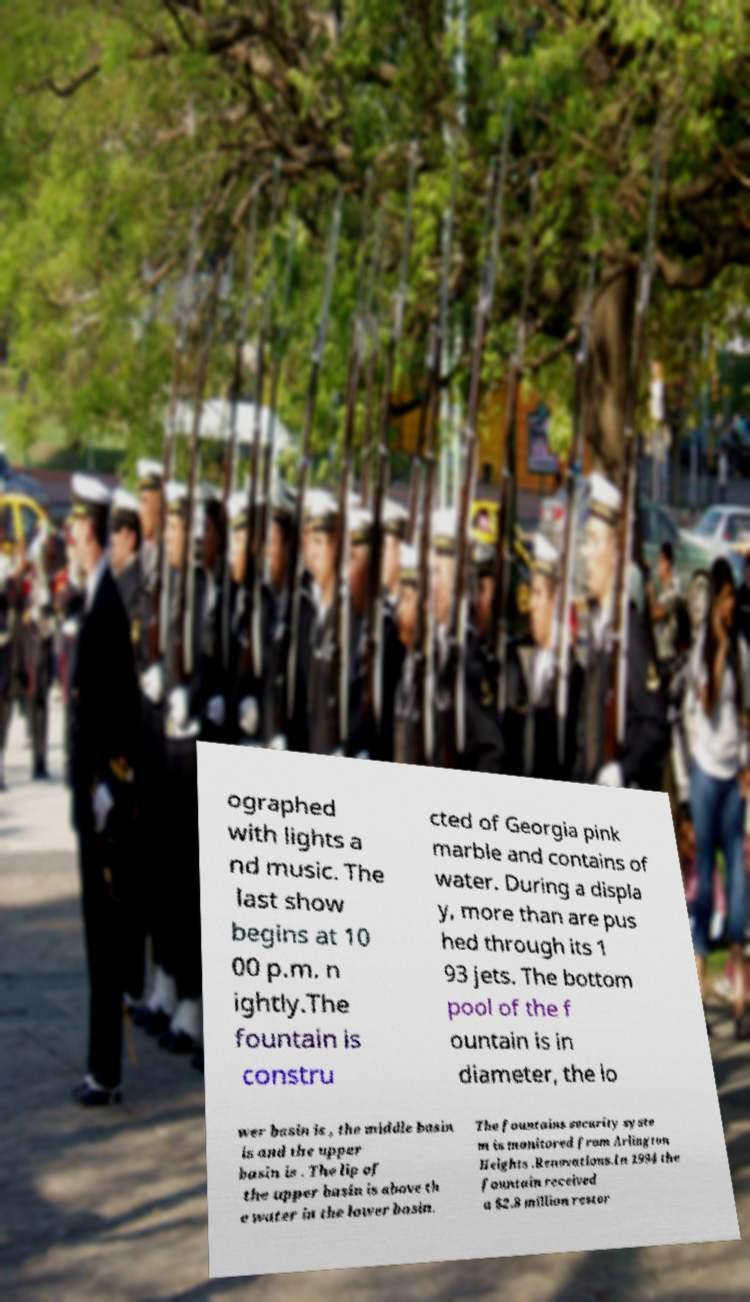Please read and relay the text visible in this image. What does it say? ographed with lights a nd music. The last show begins at 10 00 p.m. n ightly.The fountain is constru cted of Georgia pink marble and contains of water. During a displa y, more than are pus hed through its 1 93 jets. The bottom pool of the f ountain is in diameter, the lo wer basin is , the middle basin is and the upper basin is . The lip of the upper basin is above th e water in the lower basin. The fountains security syste m is monitored from Arlington Heights .Renovations.In 1994 the fountain received a $2.8 million restor 